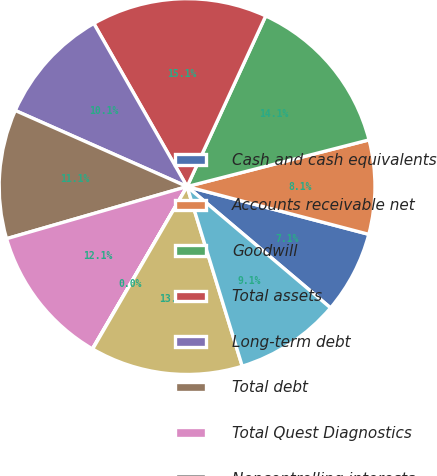Convert chart. <chart><loc_0><loc_0><loc_500><loc_500><pie_chart><fcel>Cash and cash equivalents<fcel>Accounts receivable net<fcel>Goodwill<fcel>Total assets<fcel>Long-term debt<fcel>Total debt<fcel>Total Quest Diagnostics<fcel>Noncontrolling interests<fcel>Total stockholders' equity<fcel>Net cash provided by operating<nl><fcel>7.08%<fcel>8.09%<fcel>14.13%<fcel>15.14%<fcel>10.1%<fcel>11.11%<fcel>12.12%<fcel>0.03%<fcel>13.12%<fcel>9.09%<nl></chart> 